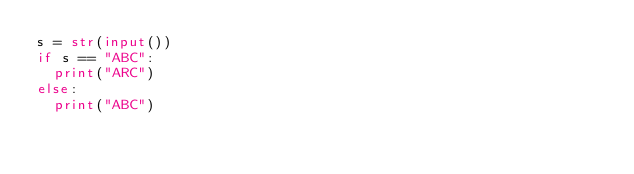<code> <loc_0><loc_0><loc_500><loc_500><_Python_>s = str(input())
if s == "ABC":
  print("ARC")
else:
  print("ABC")</code> 